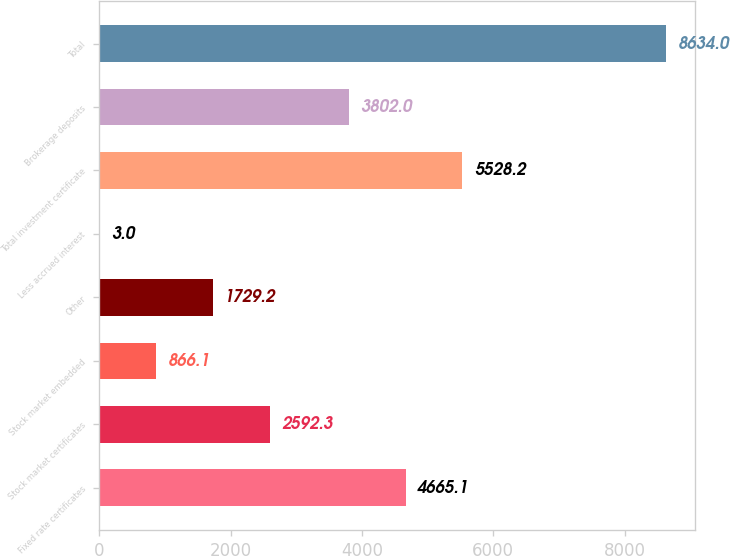Convert chart. <chart><loc_0><loc_0><loc_500><loc_500><bar_chart><fcel>Fixed rate certificates<fcel>Stock market certificates<fcel>Stock market embedded<fcel>Other<fcel>Less accrued interest<fcel>Total investment certificate<fcel>Brokerage deposits<fcel>Total<nl><fcel>4665.1<fcel>2592.3<fcel>866.1<fcel>1729.2<fcel>3<fcel>5528.2<fcel>3802<fcel>8634<nl></chart> 